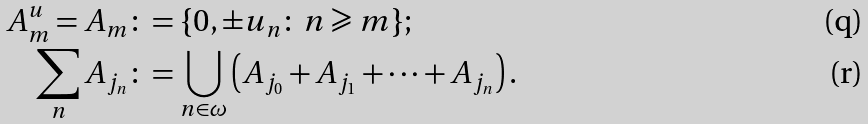Convert formula to latex. <formula><loc_0><loc_0><loc_500><loc_500>A _ { m } ^ { u } = A _ { m } & \colon = \{ 0 , \pm u _ { n } \colon \, n \geqslant m \} ; \\ \sum _ { n } A _ { j _ { n } } & \colon = \bigcup _ { n \in \omega } \left ( A _ { j _ { 0 } } + A _ { j _ { 1 } } + \dots + A _ { j _ { n } } \right ) .</formula> 